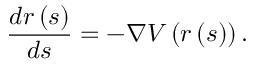Convert formula to latex. <formula><loc_0><loc_0><loc_500><loc_500>\frac { d r \left ( s \right ) } { d s } = - \nabla V \left ( r \left ( s \right ) \right ) .</formula> 